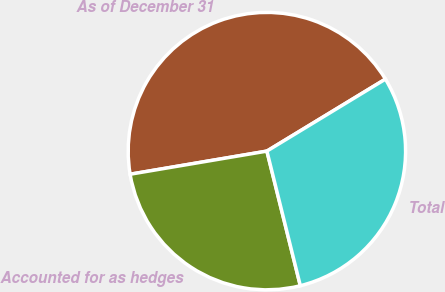Convert chart. <chart><loc_0><loc_0><loc_500><loc_500><pie_chart><fcel>As of December 31<fcel>Accounted for as hedges<fcel>Total<nl><fcel>43.98%<fcel>26.21%<fcel>29.81%<nl></chart> 